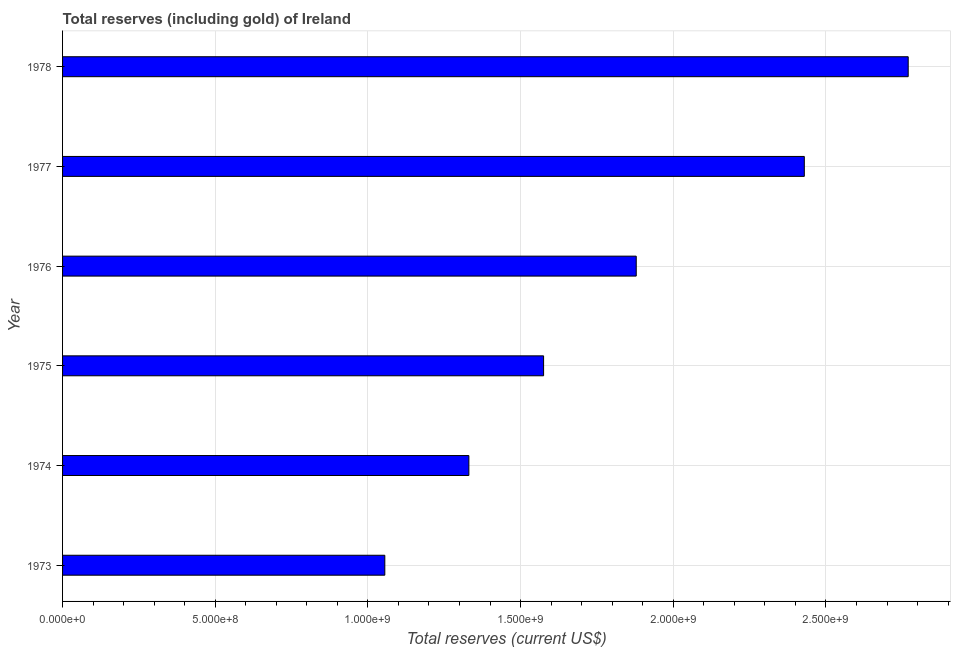Does the graph contain any zero values?
Provide a succinct answer. No. Does the graph contain grids?
Your answer should be compact. Yes. What is the title of the graph?
Provide a short and direct response. Total reserves (including gold) of Ireland. What is the label or title of the X-axis?
Keep it short and to the point. Total reserves (current US$). What is the label or title of the Y-axis?
Provide a succinct answer. Year. What is the total reserves (including gold) in 1975?
Your answer should be very brief. 1.58e+09. Across all years, what is the maximum total reserves (including gold)?
Offer a very short reply. 2.77e+09. Across all years, what is the minimum total reserves (including gold)?
Your answer should be compact. 1.06e+09. In which year was the total reserves (including gold) maximum?
Make the answer very short. 1978. In which year was the total reserves (including gold) minimum?
Your response must be concise. 1973. What is the sum of the total reserves (including gold)?
Give a very brief answer. 1.10e+1. What is the difference between the total reserves (including gold) in 1973 and 1976?
Keep it short and to the point. -8.23e+08. What is the average total reserves (including gold) per year?
Offer a terse response. 1.84e+09. What is the median total reserves (including gold)?
Make the answer very short. 1.73e+09. In how many years, is the total reserves (including gold) greater than 1500000000 US$?
Offer a very short reply. 4. Do a majority of the years between 1974 and 1978 (inclusive) have total reserves (including gold) greater than 2600000000 US$?
Ensure brevity in your answer.  No. What is the ratio of the total reserves (including gold) in 1977 to that in 1978?
Offer a terse response. 0.88. Is the difference between the total reserves (including gold) in 1973 and 1974 greater than the difference between any two years?
Your response must be concise. No. What is the difference between the highest and the second highest total reserves (including gold)?
Offer a very short reply. 3.40e+08. What is the difference between the highest and the lowest total reserves (including gold)?
Your answer should be compact. 1.71e+09. How many bars are there?
Your answer should be compact. 6. Are all the bars in the graph horizontal?
Your response must be concise. Yes. How many years are there in the graph?
Offer a terse response. 6. Are the values on the major ticks of X-axis written in scientific E-notation?
Your response must be concise. Yes. What is the Total reserves (current US$) in 1973?
Make the answer very short. 1.06e+09. What is the Total reserves (current US$) of 1974?
Make the answer very short. 1.33e+09. What is the Total reserves (current US$) of 1975?
Keep it short and to the point. 1.58e+09. What is the Total reserves (current US$) of 1976?
Make the answer very short. 1.88e+09. What is the Total reserves (current US$) of 1977?
Make the answer very short. 2.43e+09. What is the Total reserves (current US$) of 1978?
Provide a short and direct response. 2.77e+09. What is the difference between the Total reserves (current US$) in 1973 and 1974?
Give a very brief answer. -2.75e+08. What is the difference between the Total reserves (current US$) in 1973 and 1975?
Offer a terse response. -5.20e+08. What is the difference between the Total reserves (current US$) in 1973 and 1976?
Keep it short and to the point. -8.23e+08. What is the difference between the Total reserves (current US$) in 1973 and 1977?
Provide a short and direct response. -1.37e+09. What is the difference between the Total reserves (current US$) in 1973 and 1978?
Offer a very short reply. -1.71e+09. What is the difference between the Total reserves (current US$) in 1974 and 1975?
Give a very brief answer. -2.45e+08. What is the difference between the Total reserves (current US$) in 1974 and 1976?
Offer a terse response. -5.48e+08. What is the difference between the Total reserves (current US$) in 1974 and 1977?
Offer a very short reply. -1.10e+09. What is the difference between the Total reserves (current US$) in 1974 and 1978?
Ensure brevity in your answer.  -1.44e+09. What is the difference between the Total reserves (current US$) in 1975 and 1976?
Give a very brief answer. -3.03e+08. What is the difference between the Total reserves (current US$) in 1975 and 1977?
Keep it short and to the point. -8.54e+08. What is the difference between the Total reserves (current US$) in 1975 and 1978?
Offer a very short reply. -1.19e+09. What is the difference between the Total reserves (current US$) in 1976 and 1977?
Provide a succinct answer. -5.50e+08. What is the difference between the Total reserves (current US$) in 1976 and 1978?
Offer a terse response. -8.91e+08. What is the difference between the Total reserves (current US$) in 1977 and 1978?
Give a very brief answer. -3.40e+08. What is the ratio of the Total reserves (current US$) in 1973 to that in 1974?
Provide a succinct answer. 0.79. What is the ratio of the Total reserves (current US$) in 1973 to that in 1975?
Provide a short and direct response. 0.67. What is the ratio of the Total reserves (current US$) in 1973 to that in 1976?
Offer a terse response. 0.56. What is the ratio of the Total reserves (current US$) in 1973 to that in 1977?
Provide a short and direct response. 0.43. What is the ratio of the Total reserves (current US$) in 1973 to that in 1978?
Keep it short and to the point. 0.38. What is the ratio of the Total reserves (current US$) in 1974 to that in 1975?
Your answer should be very brief. 0.84. What is the ratio of the Total reserves (current US$) in 1974 to that in 1976?
Provide a short and direct response. 0.71. What is the ratio of the Total reserves (current US$) in 1974 to that in 1977?
Ensure brevity in your answer.  0.55. What is the ratio of the Total reserves (current US$) in 1974 to that in 1978?
Keep it short and to the point. 0.48. What is the ratio of the Total reserves (current US$) in 1975 to that in 1976?
Keep it short and to the point. 0.84. What is the ratio of the Total reserves (current US$) in 1975 to that in 1977?
Your response must be concise. 0.65. What is the ratio of the Total reserves (current US$) in 1975 to that in 1978?
Your answer should be compact. 0.57. What is the ratio of the Total reserves (current US$) in 1976 to that in 1977?
Your response must be concise. 0.77. What is the ratio of the Total reserves (current US$) in 1976 to that in 1978?
Offer a terse response. 0.68. What is the ratio of the Total reserves (current US$) in 1977 to that in 1978?
Your answer should be compact. 0.88. 